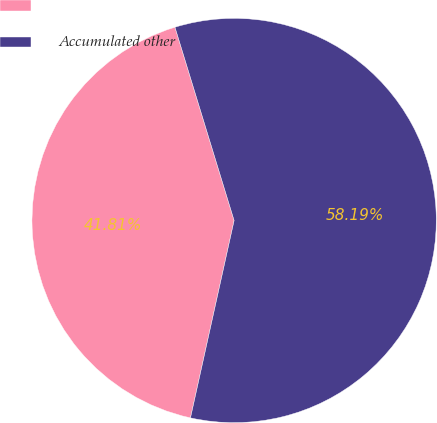<chart> <loc_0><loc_0><loc_500><loc_500><pie_chart><ecel><fcel>Accumulated other<nl><fcel>41.81%<fcel>58.19%<nl></chart> 